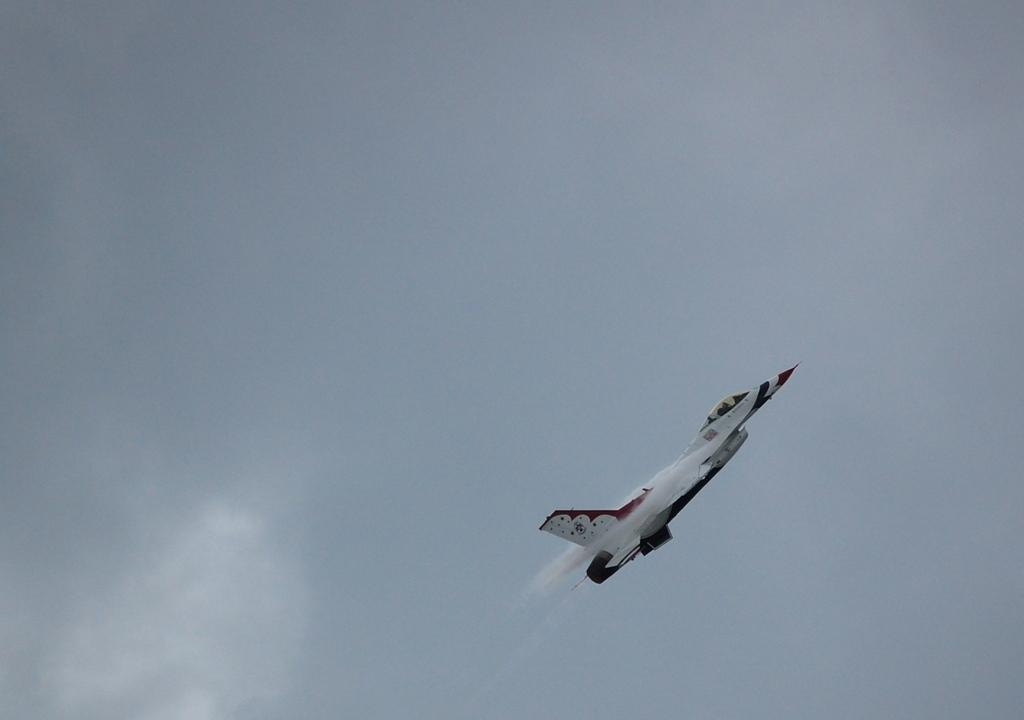What is the main subject of the image? The main subject of the image is an aircraft. What is the aircraft doing in the image? The aircraft is flying in the sky. What type of pets can be seen playing with the sound in the image? There are no pets or sound present in the image. What is the current status of the aircraft in the image? The provided facts do not mention the current status of the aircraft, only that it is flying in the sky. 